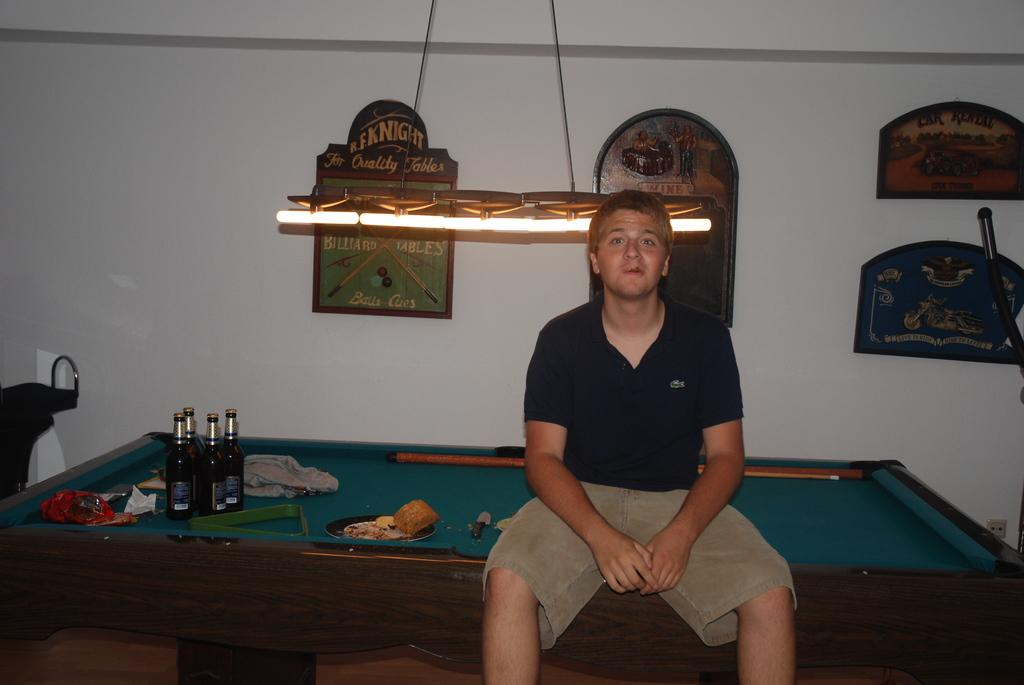What is the man doing in the image? The man is sitting on a snooker table. What can be seen in the background of the image? There are frames on the wall in the background. What else is present on the table with the man? There are bottles on the table. How much income does the man earn from playing snooker in the image? There is no information about the man's income in the image. 